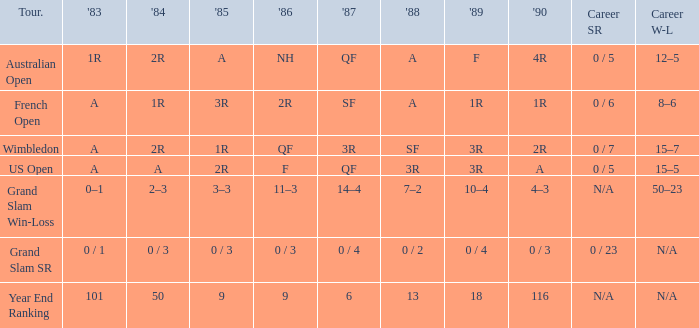In 1983, which event features a 0/1 outcome? Grand Slam SR. Parse the full table. {'header': ['Tour.', "'83", "'84", "'85", "'86", "'87", "'88", "'89", "'90", 'Career SR', 'Career W-L'], 'rows': [['Australian Open', '1R', '2R', 'A', 'NH', 'QF', 'A', 'F', '4R', '0 / 5', '12–5'], ['French Open', 'A', '1R', '3R', '2R', 'SF', 'A', '1R', '1R', '0 / 6', '8–6'], ['Wimbledon', 'A', '2R', '1R', 'QF', '3R', 'SF', '3R', '2R', '0 / 7', '15–7'], ['US Open', 'A', 'A', '2R', 'F', 'QF', '3R', '3R', 'A', '0 / 5', '15–5'], ['Grand Slam Win-Loss', '0–1', '2–3', '3–3', '11–3', '14–4', '7–2', '10–4', '4–3', 'N/A', '50–23'], ['Grand Slam SR', '0 / 1', '0 / 3', '0 / 3', '0 / 3', '0 / 4', '0 / 2', '0 / 4', '0 / 3', '0 / 23', 'N/A'], ['Year End Ranking', '101', '50', '9', '9', '6', '13', '18', '116', 'N/A', 'N/A']]} 